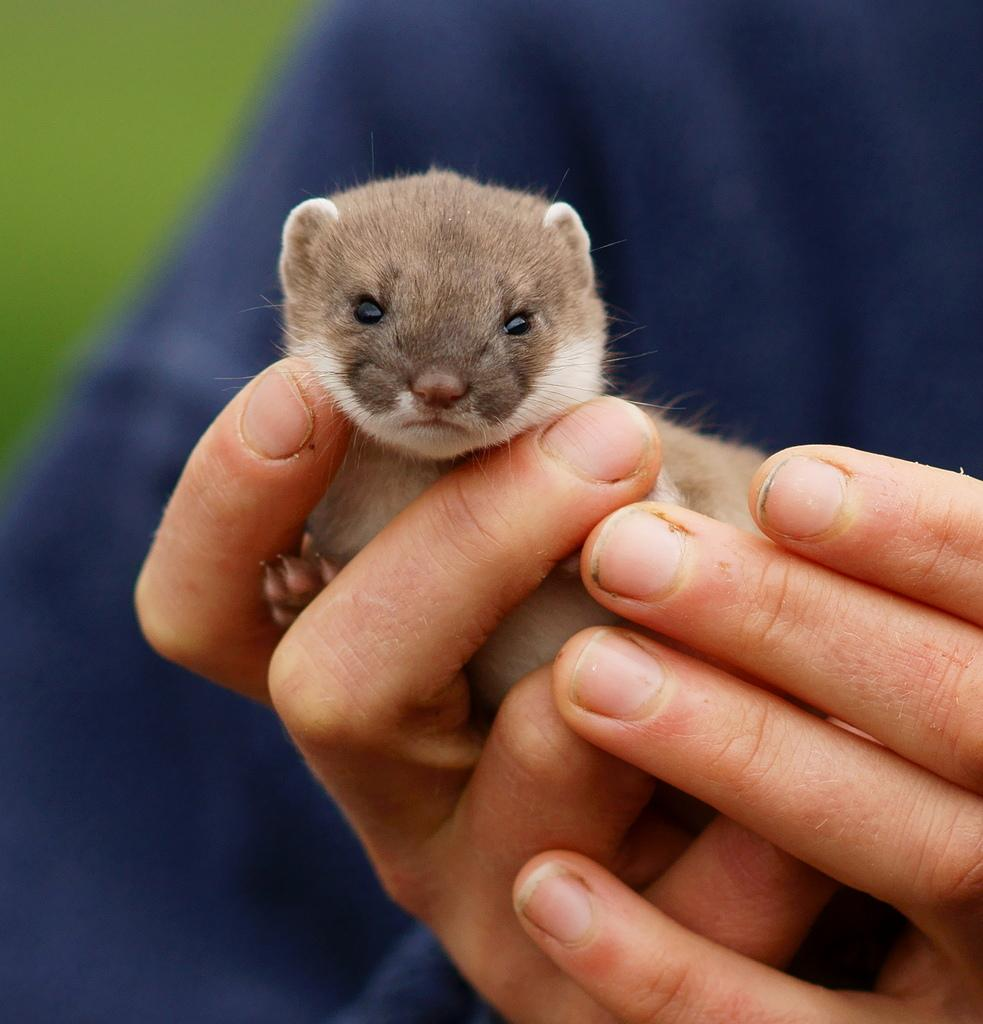What is the person in the image holding? The person is holding an animal in the image. Can you describe the background of the image? The background of the image is blurred. What type of oil can be seen dripping from the animal in the image? There is no oil present in the image, and the animal is not depicted as dripping anything. 